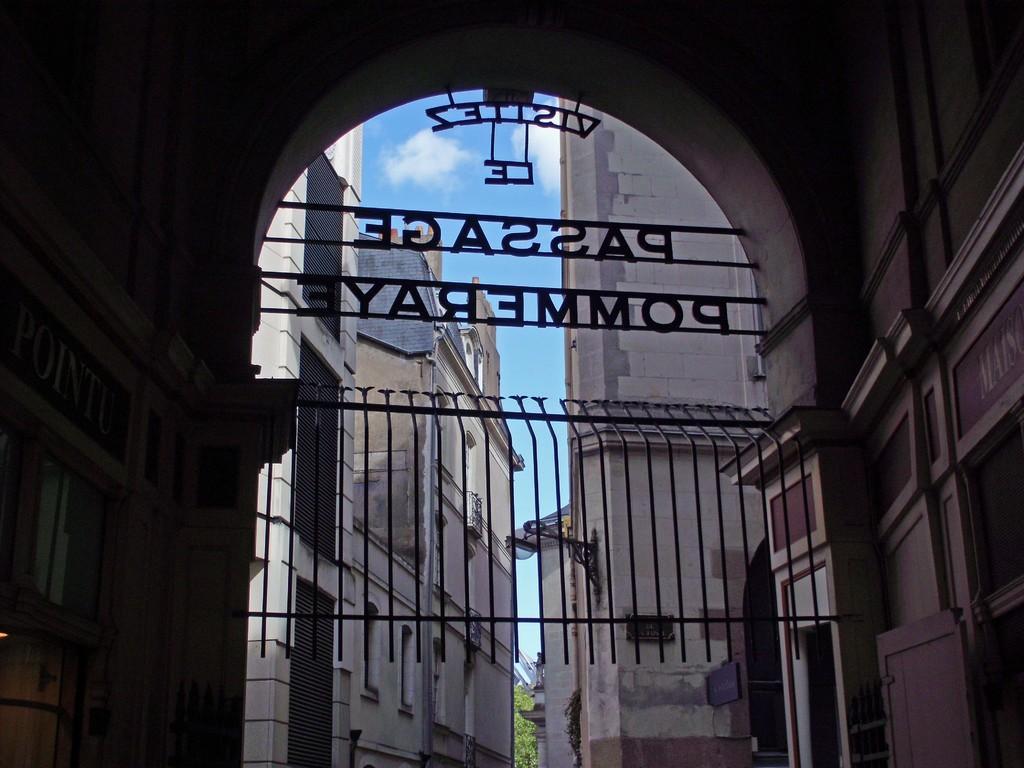Describe this image in one or two sentences. In this image we can see a building, here is the arch, here is the fencing, here is the wall, here is the tree, at above here is the sky. 